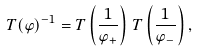Convert formula to latex. <formula><loc_0><loc_0><loc_500><loc_500>T ( \varphi ) ^ { - 1 } = T \left ( \frac { 1 } { \varphi _ { + } } \right ) \, T \left ( \frac { 1 } { \varphi _ { - } } \right ) ,</formula> 